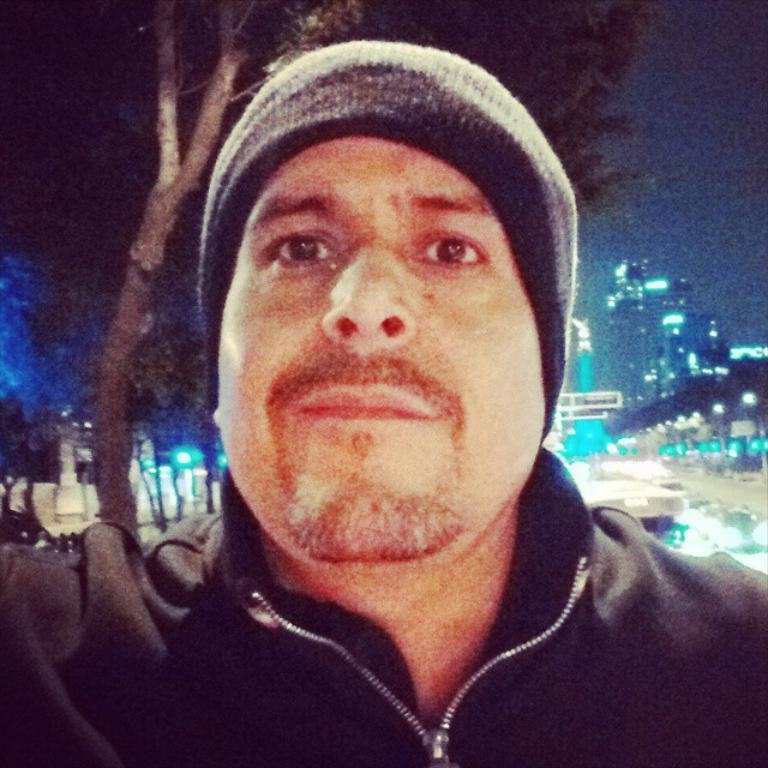What is the main subject in the foreground of the image? There is a man wearing a hat in the foreground of the image. What can be seen in the background of the image? There are buildings, trees, and lights in the background of the image. What is visible at the top of the image? The sky is visible at the top of the image. What type of cord is being used to support the moon in the image? There is no moon present in the image, and therefore no cord is being used to support it. 